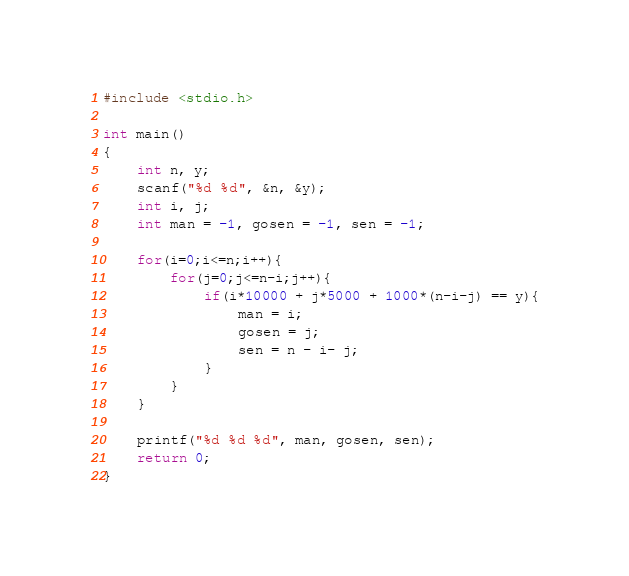<code> <loc_0><loc_0><loc_500><loc_500><_C_>#include <stdio.h>

int main()
{
    int n, y;
    scanf("%d %d", &n, &y);
    int i, j;
    int man = -1, gosen = -1, sen = -1;
    
    for(i=0;i<=n;i++){
        for(j=0;j<=n-i;j++){
            if(i*10000 + j*5000 + 1000*(n-i-j) == y){
                man = i;
                gosen = j;
                sen = n - i- j;
            }
        }
    }
    
    printf("%d %d %d", man, gosen, sen);
    return 0;
}
</code> 